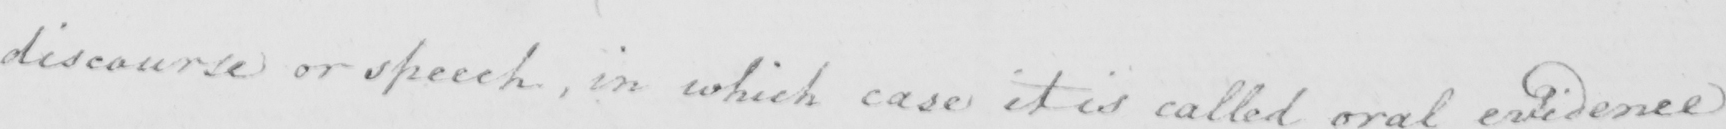What text is written in this handwritten line? discourse or speech , in which case it is called oral evidence 